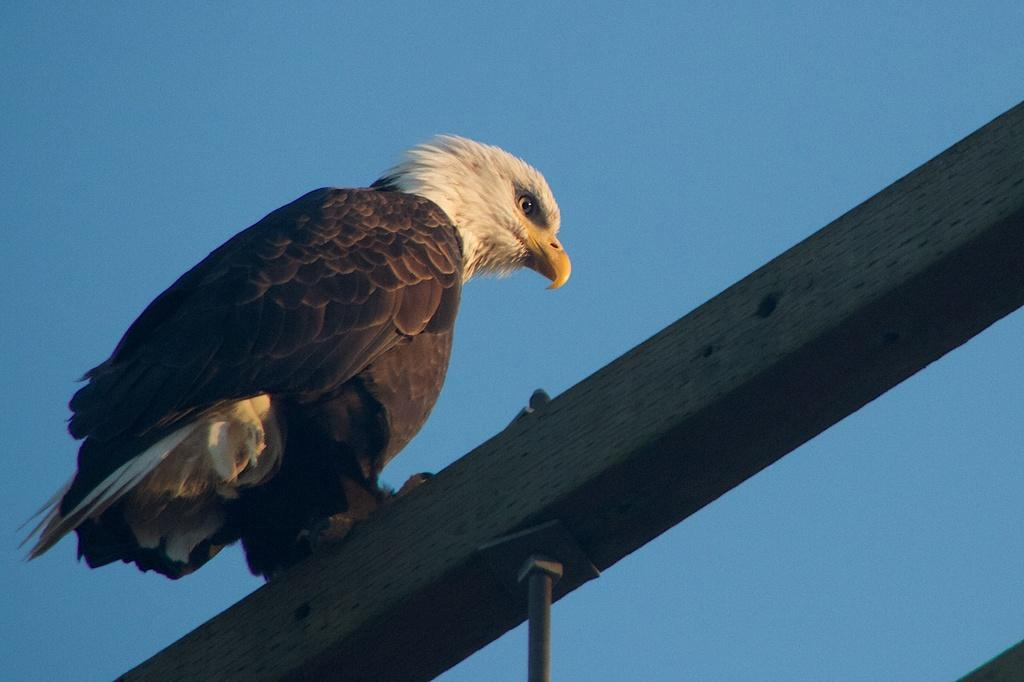What animal is the main subject of the image? There is an eagle in the image. What is the eagle standing on? The eagle is standing on an iron rod. What can be seen in the background of the image? There is a blue sky visible in the background of the image. How many kettles are visible in the image? There are no kettles present in the image. What type of stretch is the eagle performing in the image? The eagle is not performing any stretch in the image; it is standing on an iron rod. 